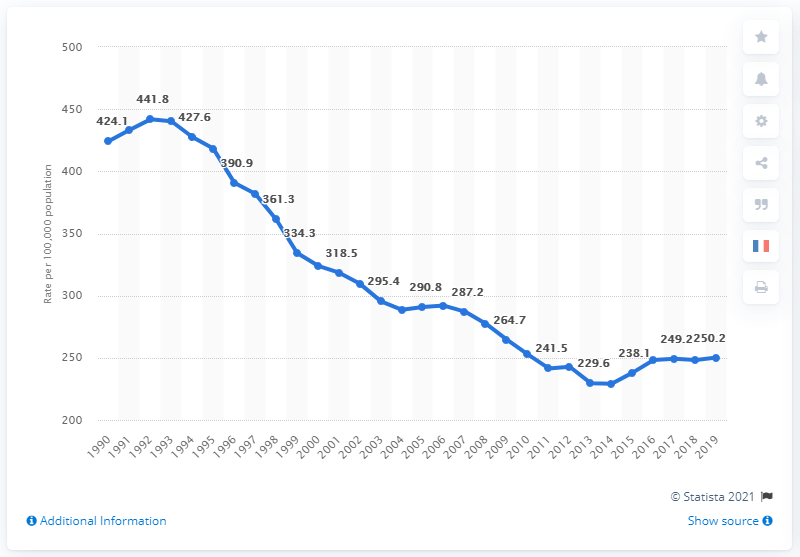Draw attention to some important aspects in this diagram. In 2019, the national aggravated assault rate was 250.2 per 100,000 population. 